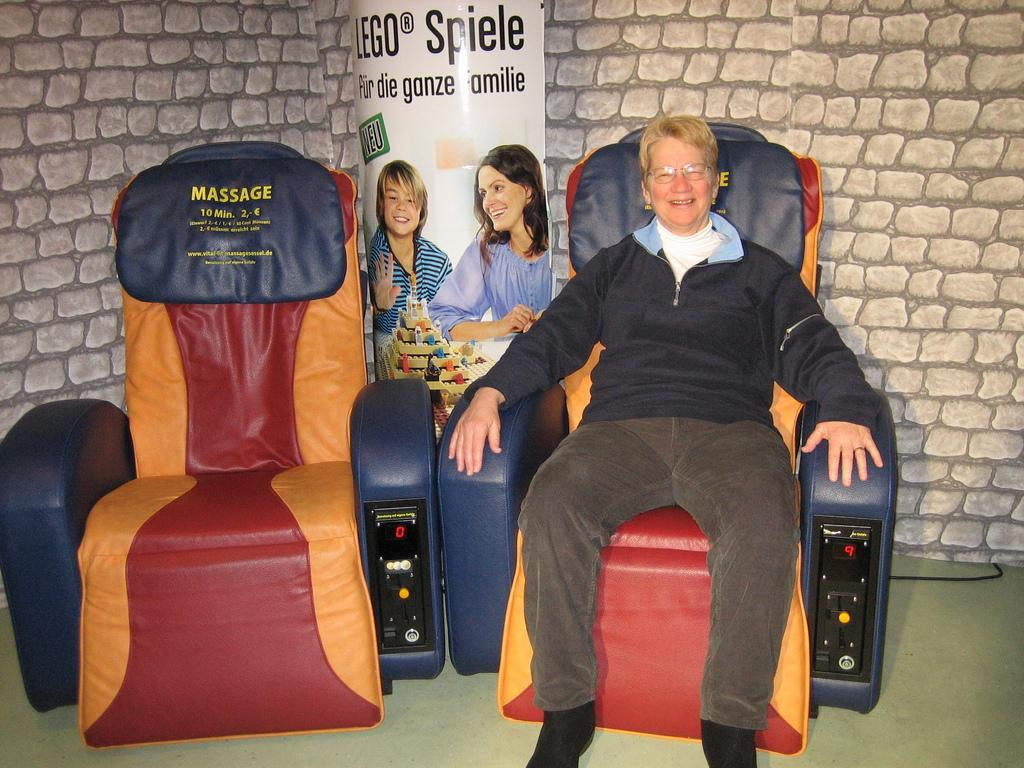What is the person in the image doing? The person is sitting on a chair in the image. How many chairs are visible in the image? There are two chairs visible in the image, with one being occupied by the person. What can be seen in the background of the image? There is a poster and a wall in the background of the image. What type of string can be seen holding the chair in the image? There is no string visible in the image, and the chair is not being held up by any string. 